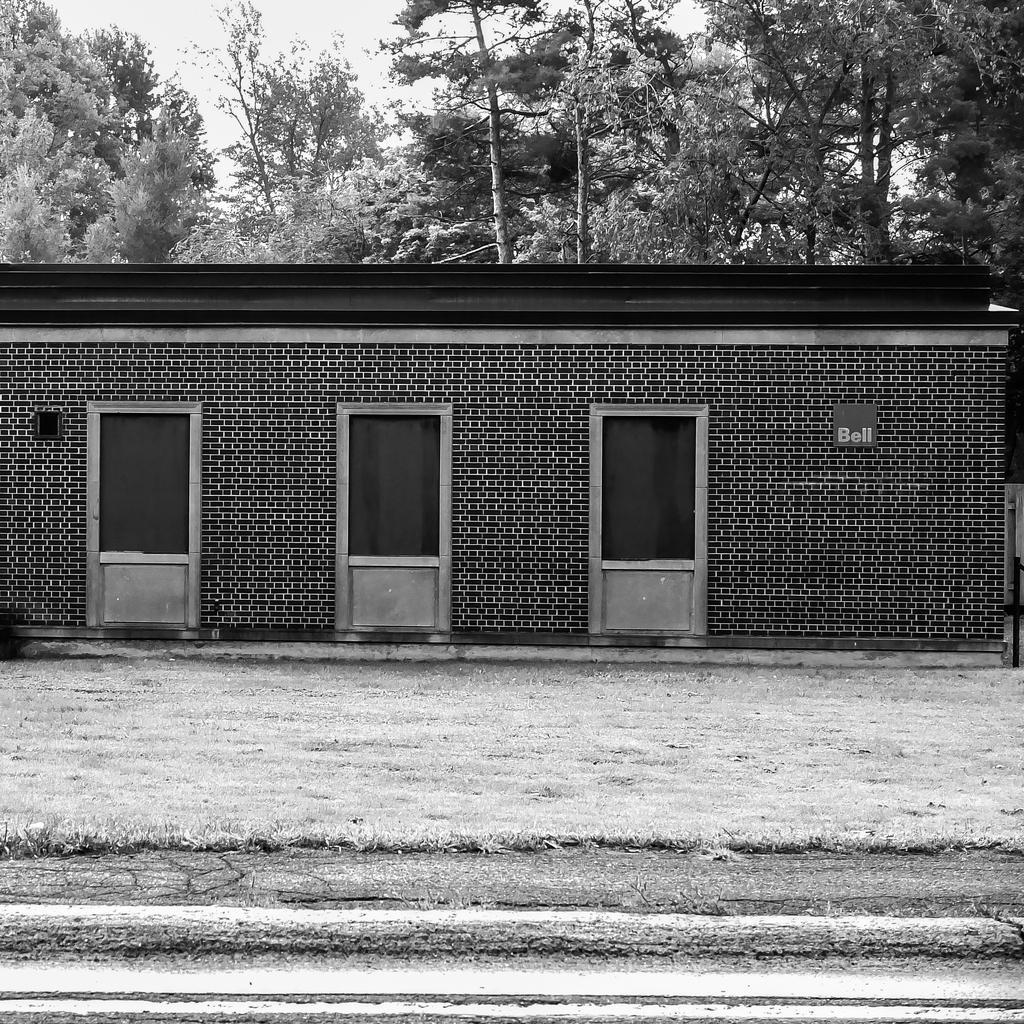Please provide a concise description of this image. In this image I can see three doors attached to the building, at back I can see tree and sky and the image is in black and white. 